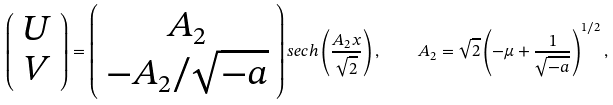<formula> <loc_0><loc_0><loc_500><loc_500>\left ( \begin{array} { c } U \\ V \end{array} \right ) = \left ( \begin{array} { c } A _ { 2 } \\ - A _ { 2 } / \sqrt { - a } \end{array} \right ) s e c h \left ( \frac { A _ { 2 } x } { \sqrt { 2 } } \right ) , \quad A _ { 2 } = \sqrt { 2 } \left ( - \mu + \frac { 1 } { \sqrt { - a } } \right ) ^ { 1 / 2 } ,</formula> 